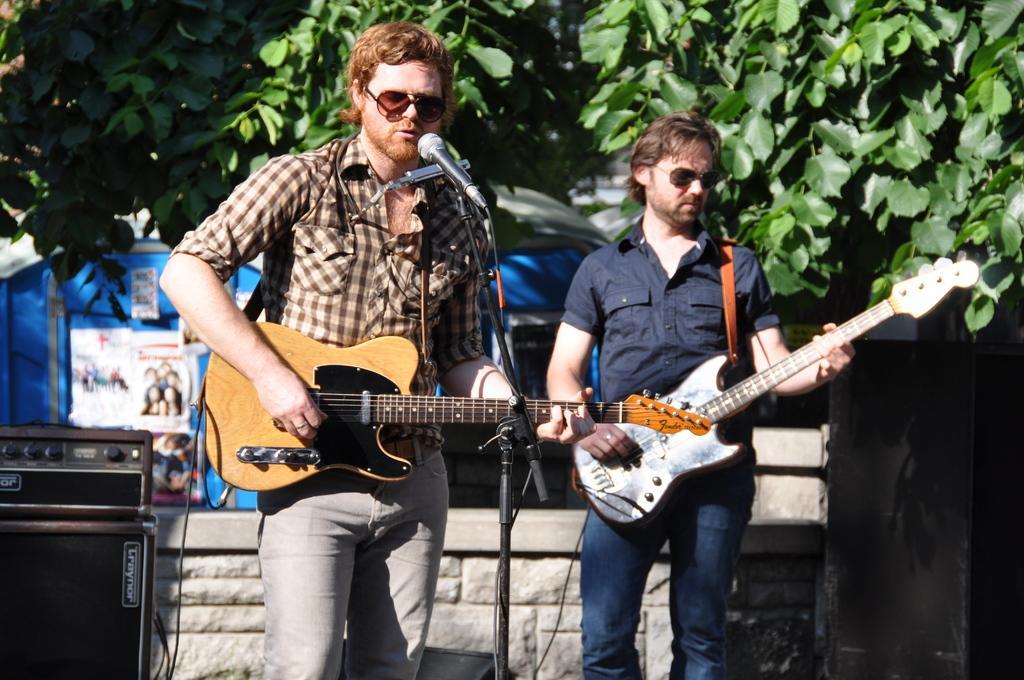Please provide a concise description of this image. In this image In the middle there is a man he wears check shirt and trouser he is playing guitar in front of him there is a mic. On the right there is a man he wears shirt and trouser he is playing guitar. In the background there are trees,tent and speakers. 